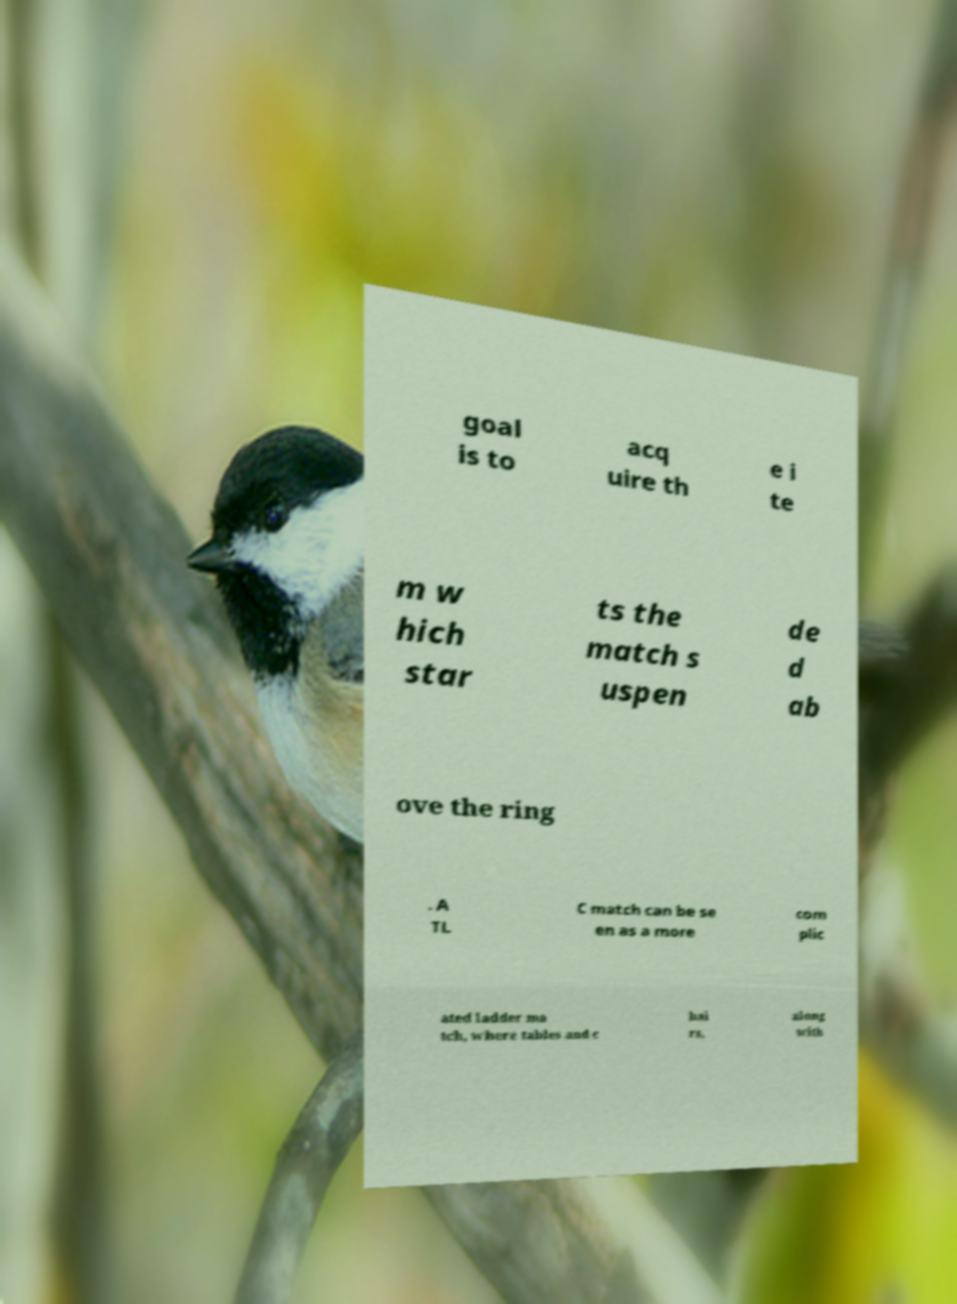I need the written content from this picture converted into text. Can you do that? goal is to acq uire th e i te m w hich star ts the match s uspen de d ab ove the ring . A TL C match can be se en as a more com plic ated ladder ma tch, where tables and c hai rs, along with 